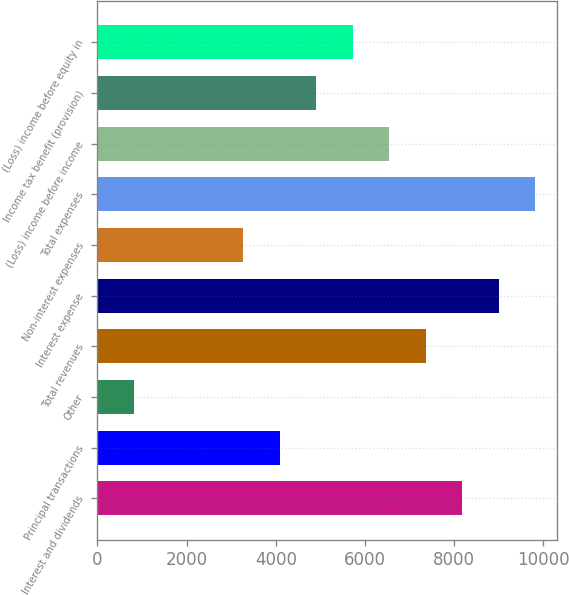<chart> <loc_0><loc_0><loc_500><loc_500><bar_chart><fcel>Interest and dividends<fcel>Principal transactions<fcel>Other<fcel>Total revenues<fcel>Interest expense<fcel>Non-interest expenses<fcel>Total expenses<fcel>(Loss) income before income<fcel>Income tax benefit (provision)<fcel>(Loss) income before equity in<nl><fcel>8183<fcel>4092.5<fcel>820.1<fcel>7364.9<fcel>9001.1<fcel>3274.4<fcel>9819.2<fcel>6546.8<fcel>4910.6<fcel>5728.7<nl></chart> 